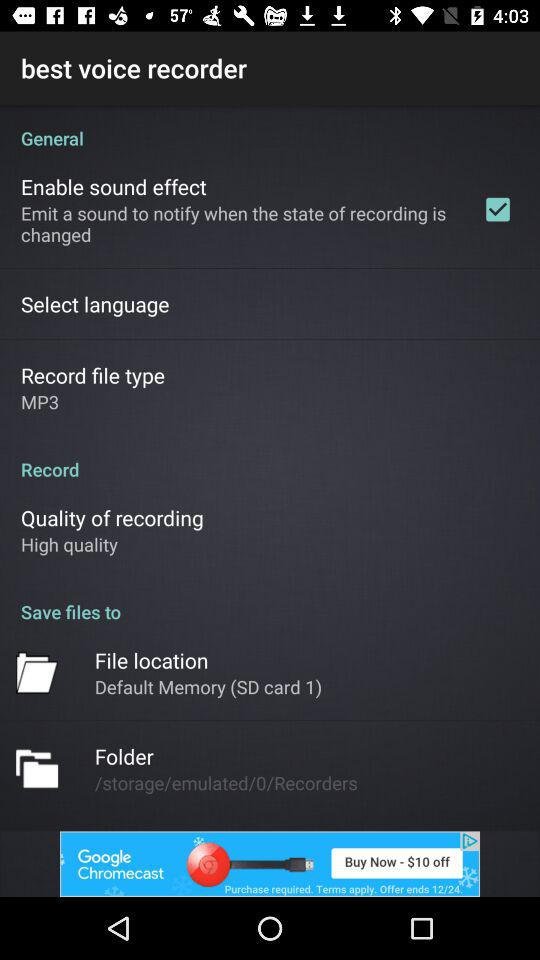How many items are under the 'Save files to' section?
Answer the question using a single word or phrase. 2 